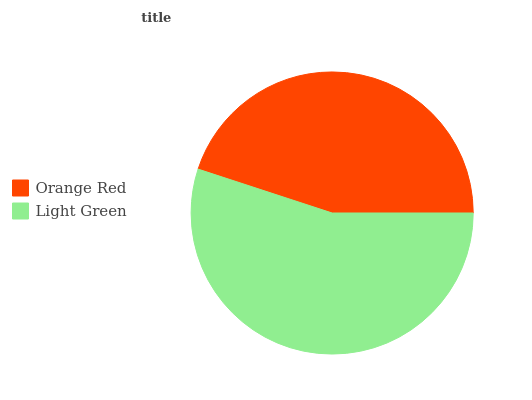Is Orange Red the minimum?
Answer yes or no. Yes. Is Light Green the maximum?
Answer yes or no. Yes. Is Light Green the minimum?
Answer yes or no. No. Is Light Green greater than Orange Red?
Answer yes or no. Yes. Is Orange Red less than Light Green?
Answer yes or no. Yes. Is Orange Red greater than Light Green?
Answer yes or no. No. Is Light Green less than Orange Red?
Answer yes or no. No. Is Light Green the high median?
Answer yes or no. Yes. Is Orange Red the low median?
Answer yes or no. Yes. Is Orange Red the high median?
Answer yes or no. No. Is Light Green the low median?
Answer yes or no. No. 